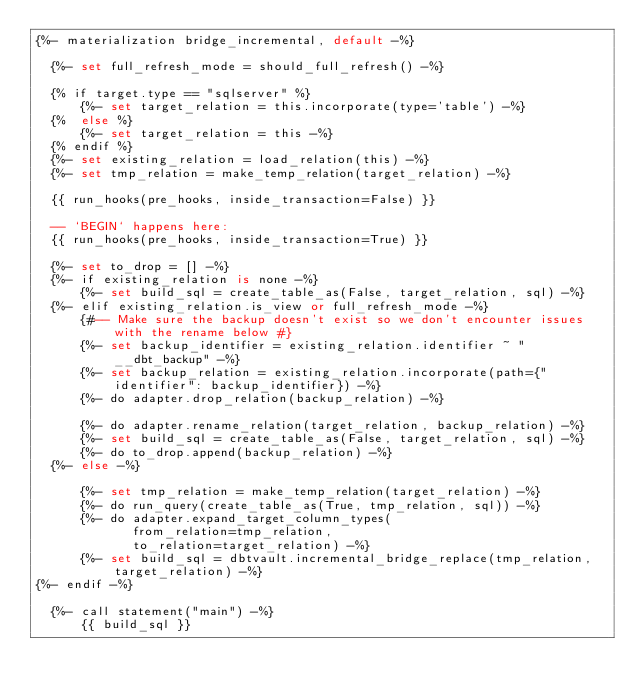Convert code to text. <code><loc_0><loc_0><loc_500><loc_500><_SQL_>{%- materialization bridge_incremental, default -%}

  {%- set full_refresh_mode = should_full_refresh() -%}

  {% if target.type == "sqlserver" %}
      {%- set target_relation = this.incorporate(type='table') -%}
  {%  else %}
      {%- set target_relation = this -%}
  {% endif %}
  {%- set existing_relation = load_relation(this) -%}
  {%- set tmp_relation = make_temp_relation(target_relation) -%}

  {{ run_hooks(pre_hooks, inside_transaction=False) }}

  -- `BEGIN` happens here:
  {{ run_hooks(pre_hooks, inside_transaction=True) }}

  {%- set to_drop = [] -%}
  {%- if existing_relation is none -%}
      {%- set build_sql = create_table_as(False, target_relation, sql) -%}
  {%- elif existing_relation.is_view or full_refresh_mode -%}
      {#-- Make sure the backup doesn't exist so we don't encounter issues with the rename below #}
      {%- set backup_identifier = existing_relation.identifier ~ "__dbt_backup" -%}
      {%- set backup_relation = existing_relation.incorporate(path={"identifier": backup_identifier}) -%}
      {%- do adapter.drop_relation(backup_relation) -%}

      {%- do adapter.rename_relation(target_relation, backup_relation) -%}
      {%- set build_sql = create_table_as(False, target_relation, sql) -%}
      {%- do to_drop.append(backup_relation) -%}
  {%- else -%}

      {%- set tmp_relation = make_temp_relation(target_relation) -%}
      {%- do run_query(create_table_as(True, tmp_relation, sql)) -%}
      {%- do adapter.expand_target_column_types(
             from_relation=tmp_relation,
             to_relation=target_relation) -%}
      {%- set build_sql = dbtvault.incremental_bridge_replace(tmp_relation, target_relation) -%}
{%- endif -%}

  {%- call statement("main") -%}
      {{ build_sql }}</code> 